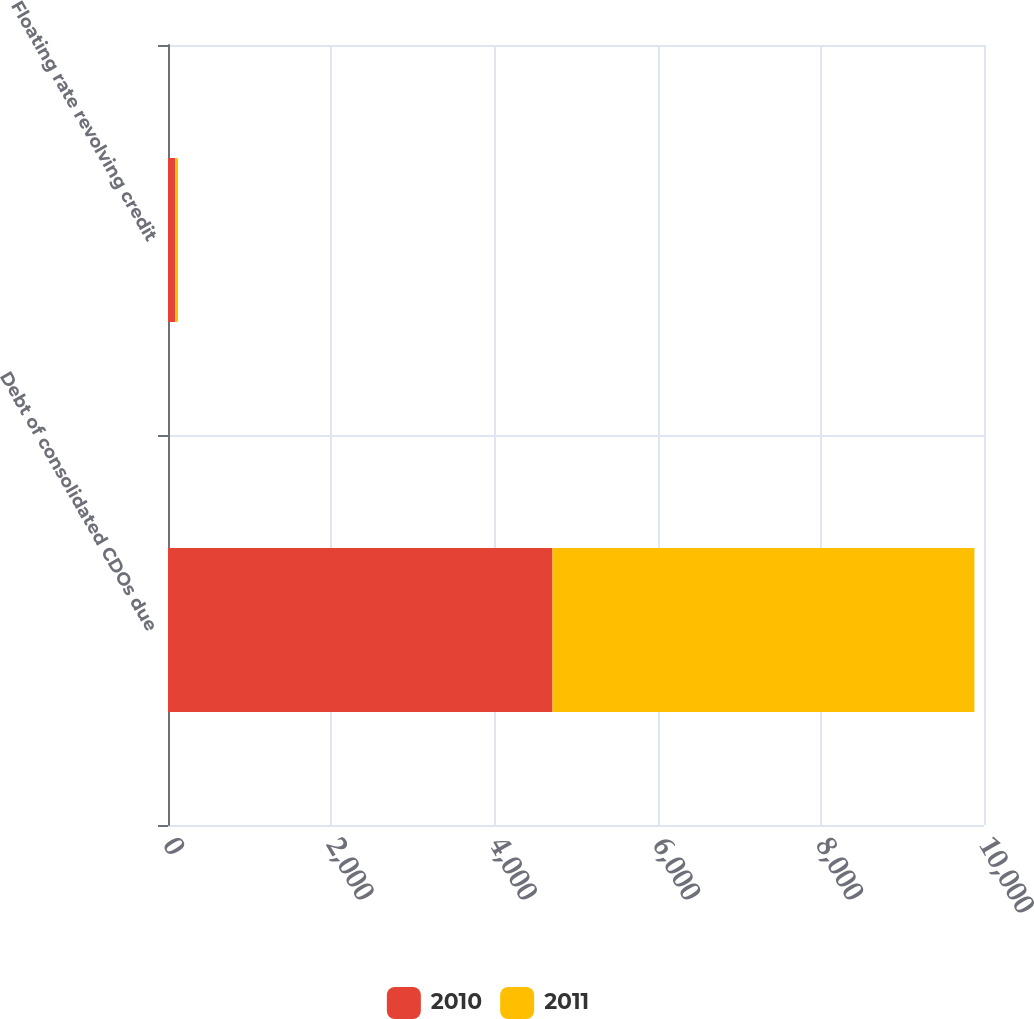<chart> <loc_0><loc_0><loc_500><loc_500><stacked_bar_chart><ecel><fcel>Debt of consolidated CDOs due<fcel>Floating rate revolving credit<nl><fcel>2010<fcel>4712<fcel>88<nl><fcel>2011<fcel>5171<fcel>35<nl></chart> 